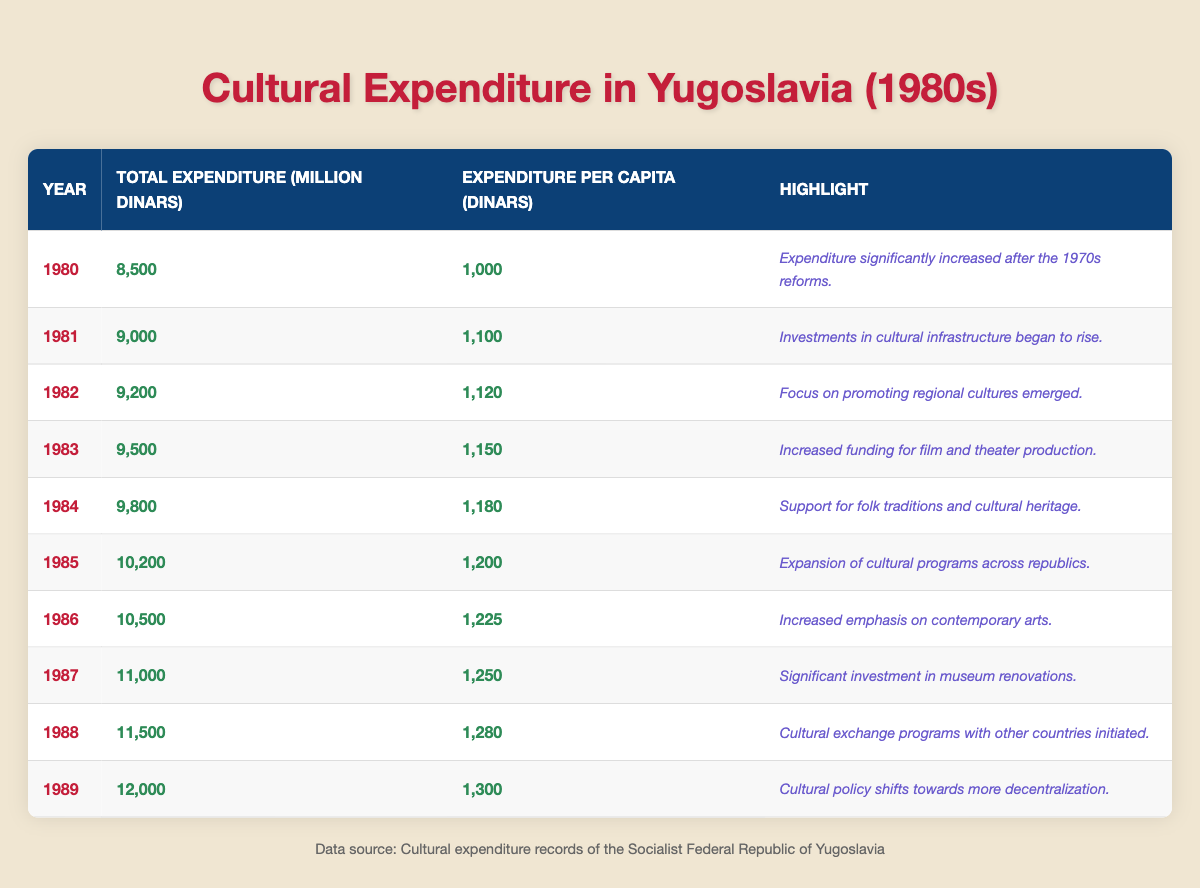What was the total cultural expenditure in Yugoslavia in 1982? The table shows that the total expenditure in 1982 was 9,200 million dinars.
Answer: 9,200 million dinars What was the expenditure per capita in 1985? According to the table, the expenditure per capita in 1985 was 1,200 dinars.
Answer: 1,200 dinars How much did the expenditure per capita increase from 1980 to 1989? In 1980, the expenditure per capita was 1,000 dinars, and in 1989, it was 1,300 dinars. The increase is 1,300 - 1,000 = 300 dinars.
Answer: 300 dinars Which year had the highest cultural expenditure per capita? The year 1989 had the highest expenditure per capita at 1,300 dinars.
Answer: 1989 Did the total cultural expenditure increase every year in the 1980s? The table shows a steady increase in total expenditure each year from 1980 to 1989, indicating it did increase every year.
Answer: Yes What was the relationship between total expenditure and expenditure per capita in the years analyzed? As the total expenditure increased each year, the expenditure per capita also increased, indicating a positive relationship.
Answer: Positive relationship What was the average total cultural expenditure from 1980 to 1989? To find the average total expenditure, sum all expenditures (8,500 + 9,000 + 9,200 + 9,500 + 9,800 + 10,200 + 10,500 + 11,000 + 11,500 + 12,000) = 99,700 million dinars. Then, divide by 10 (the number of years): 99,700 / 10 = 9,970 million dinars.
Answer: 9,970 million dinars Which year had the smallest increase in expenditure per capita compared to the previous year? The increase in expenditure per capita was smallest from 1987 to 1988 (from 1,250 to 1,280), an increase of 30 dinars, compared to other years.
Answer: 1987 to 1988 What was emphasized as important in cultural policy from 1986 onward? The highlights from 1986 onward mention increased emphasis on contemporary arts, significant investment in museum renovations, and the initiation of cultural exchange programs, indicating a shift towards contemporary focus and international collaboration.
Answer: Contemporary focus and international collaboration How much total expenditure was spent on cultural programs in the year 1984 compared to 1983? The total expenditure in 1984 was 9,800 million dinars and in 1983 it was 9,500 million dinars, showing an increase of 300 million dinars from 1983 to 1984.
Answer: 300 million dinars more in 1984 